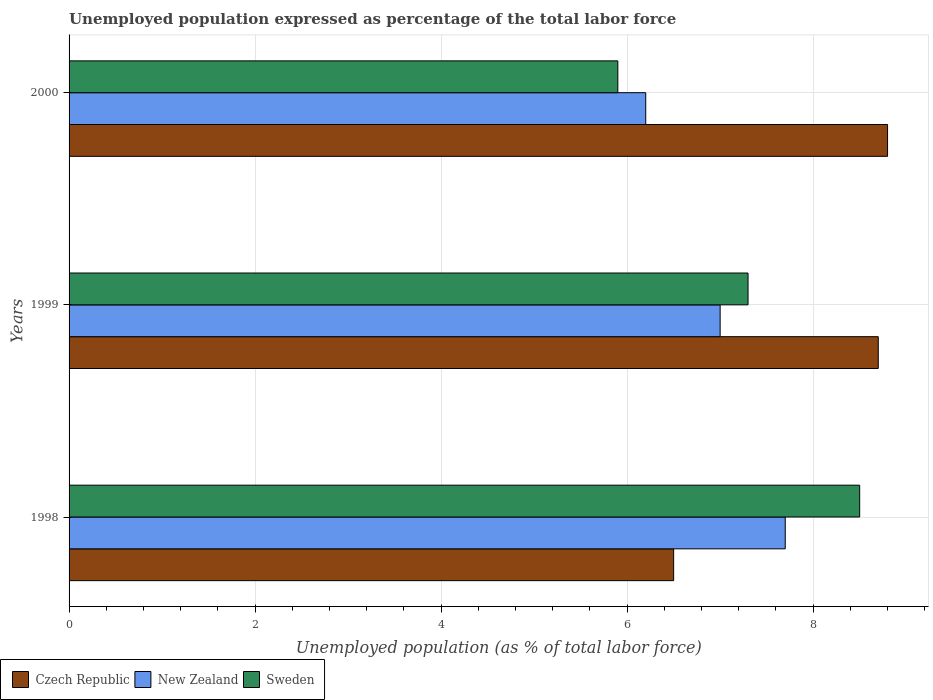Are the number of bars per tick equal to the number of legend labels?
Your answer should be very brief. Yes. Are the number of bars on each tick of the Y-axis equal?
Make the answer very short. Yes. How many bars are there on the 3rd tick from the top?
Provide a short and direct response. 3. In how many cases, is the number of bars for a given year not equal to the number of legend labels?
Make the answer very short. 0. What is the unemployment in in Czech Republic in 2000?
Your response must be concise. 8.8. Across all years, what is the minimum unemployment in in New Zealand?
Ensure brevity in your answer.  6.2. In which year was the unemployment in in Czech Republic maximum?
Ensure brevity in your answer.  2000. In which year was the unemployment in in New Zealand minimum?
Give a very brief answer. 2000. What is the total unemployment in in New Zealand in the graph?
Offer a very short reply. 20.9. What is the difference between the unemployment in in Czech Republic in 1998 and that in 2000?
Your answer should be very brief. -2.3. What is the difference between the unemployment in in Sweden in 2000 and the unemployment in in New Zealand in 1999?
Ensure brevity in your answer.  -1.1. What is the average unemployment in in New Zealand per year?
Make the answer very short. 6.97. In the year 1999, what is the difference between the unemployment in in New Zealand and unemployment in in Sweden?
Keep it short and to the point. -0.3. What is the ratio of the unemployment in in New Zealand in 1999 to that in 2000?
Your answer should be very brief. 1.13. Is the unemployment in in Sweden in 1998 less than that in 1999?
Make the answer very short. No. Is the difference between the unemployment in in New Zealand in 1999 and 2000 greater than the difference between the unemployment in in Sweden in 1999 and 2000?
Give a very brief answer. No. What is the difference between the highest and the second highest unemployment in in Sweden?
Your response must be concise. 1.2. What is the difference between the highest and the lowest unemployment in in Czech Republic?
Your answer should be very brief. 2.3. What does the 2nd bar from the top in 1998 represents?
Your answer should be very brief. New Zealand. What does the 2nd bar from the bottom in 1999 represents?
Offer a very short reply. New Zealand. How many bars are there?
Offer a terse response. 9. How many years are there in the graph?
Your answer should be compact. 3. What is the difference between two consecutive major ticks on the X-axis?
Your answer should be compact. 2. Does the graph contain grids?
Your response must be concise. Yes. How are the legend labels stacked?
Offer a very short reply. Horizontal. What is the title of the graph?
Make the answer very short. Unemployed population expressed as percentage of the total labor force. Does "Estonia" appear as one of the legend labels in the graph?
Keep it short and to the point. No. What is the label or title of the X-axis?
Provide a succinct answer. Unemployed population (as % of total labor force). What is the Unemployed population (as % of total labor force) in New Zealand in 1998?
Keep it short and to the point. 7.7. What is the Unemployed population (as % of total labor force) of Czech Republic in 1999?
Your response must be concise. 8.7. What is the Unemployed population (as % of total labor force) of New Zealand in 1999?
Your answer should be very brief. 7. What is the Unemployed population (as % of total labor force) of Sweden in 1999?
Keep it short and to the point. 7.3. What is the Unemployed population (as % of total labor force) of Czech Republic in 2000?
Offer a very short reply. 8.8. What is the Unemployed population (as % of total labor force) in New Zealand in 2000?
Your answer should be very brief. 6.2. What is the Unemployed population (as % of total labor force) of Sweden in 2000?
Keep it short and to the point. 5.9. Across all years, what is the maximum Unemployed population (as % of total labor force) in Czech Republic?
Your answer should be compact. 8.8. Across all years, what is the maximum Unemployed population (as % of total labor force) of New Zealand?
Make the answer very short. 7.7. Across all years, what is the minimum Unemployed population (as % of total labor force) of New Zealand?
Keep it short and to the point. 6.2. Across all years, what is the minimum Unemployed population (as % of total labor force) of Sweden?
Make the answer very short. 5.9. What is the total Unemployed population (as % of total labor force) in New Zealand in the graph?
Your response must be concise. 20.9. What is the total Unemployed population (as % of total labor force) of Sweden in the graph?
Provide a succinct answer. 21.7. What is the difference between the Unemployed population (as % of total labor force) in Czech Republic in 1998 and that in 1999?
Offer a terse response. -2.2. What is the difference between the Unemployed population (as % of total labor force) of Sweden in 1998 and that in 1999?
Provide a short and direct response. 1.2. What is the difference between the Unemployed population (as % of total labor force) in New Zealand in 1998 and that in 2000?
Offer a terse response. 1.5. What is the difference between the Unemployed population (as % of total labor force) of Czech Republic in 1999 and that in 2000?
Provide a short and direct response. -0.1. What is the difference between the Unemployed population (as % of total labor force) in New Zealand in 1999 and that in 2000?
Keep it short and to the point. 0.8. What is the difference between the Unemployed population (as % of total labor force) of Sweden in 1999 and that in 2000?
Offer a terse response. 1.4. What is the difference between the Unemployed population (as % of total labor force) in New Zealand in 1998 and the Unemployed population (as % of total labor force) in Sweden in 1999?
Your response must be concise. 0.4. What is the difference between the Unemployed population (as % of total labor force) of Czech Republic in 1999 and the Unemployed population (as % of total labor force) of New Zealand in 2000?
Make the answer very short. 2.5. What is the difference between the Unemployed population (as % of total labor force) of Czech Republic in 1999 and the Unemployed population (as % of total labor force) of Sweden in 2000?
Provide a succinct answer. 2.8. What is the average Unemployed population (as % of total labor force) in New Zealand per year?
Offer a very short reply. 6.97. What is the average Unemployed population (as % of total labor force) of Sweden per year?
Your answer should be very brief. 7.23. In the year 1998, what is the difference between the Unemployed population (as % of total labor force) of Czech Republic and Unemployed population (as % of total labor force) of New Zealand?
Offer a terse response. -1.2. In the year 2000, what is the difference between the Unemployed population (as % of total labor force) of New Zealand and Unemployed population (as % of total labor force) of Sweden?
Ensure brevity in your answer.  0.3. What is the ratio of the Unemployed population (as % of total labor force) in Czech Republic in 1998 to that in 1999?
Keep it short and to the point. 0.75. What is the ratio of the Unemployed population (as % of total labor force) of Sweden in 1998 to that in 1999?
Your response must be concise. 1.16. What is the ratio of the Unemployed population (as % of total labor force) in Czech Republic in 1998 to that in 2000?
Ensure brevity in your answer.  0.74. What is the ratio of the Unemployed population (as % of total labor force) in New Zealand in 1998 to that in 2000?
Offer a very short reply. 1.24. What is the ratio of the Unemployed population (as % of total labor force) in Sweden in 1998 to that in 2000?
Provide a short and direct response. 1.44. What is the ratio of the Unemployed population (as % of total labor force) of New Zealand in 1999 to that in 2000?
Your answer should be very brief. 1.13. What is the ratio of the Unemployed population (as % of total labor force) of Sweden in 1999 to that in 2000?
Your answer should be very brief. 1.24. What is the difference between the highest and the second highest Unemployed population (as % of total labor force) of Czech Republic?
Offer a very short reply. 0.1. What is the difference between the highest and the lowest Unemployed population (as % of total labor force) in Czech Republic?
Ensure brevity in your answer.  2.3. What is the difference between the highest and the lowest Unemployed population (as % of total labor force) of New Zealand?
Give a very brief answer. 1.5. 